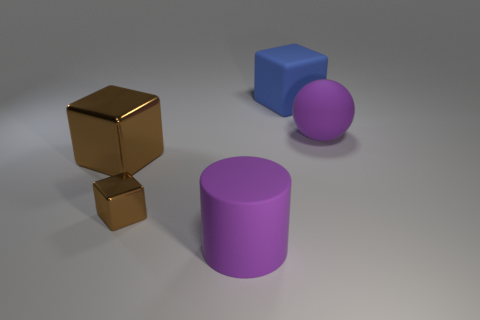Does the big sphere have the same color as the big cylinder?
Provide a succinct answer. Yes. Is there anything else that is the same shape as the small thing?
Keep it short and to the point. Yes. There is a large cube behind the object right of the blue matte block; what is it made of?
Ensure brevity in your answer.  Rubber. What is the size of the matte object that is to the left of the blue rubber object?
Make the answer very short. Large. There is a object that is both in front of the large metal object and on the left side of the purple matte cylinder; what color is it?
Ensure brevity in your answer.  Brown. There is a purple thing that is on the left side of the purple matte sphere; is its size the same as the big blue cube?
Your response must be concise. Yes. There is a rubber object behind the big purple ball; are there any large blue things left of it?
Offer a terse response. No. What is the material of the big brown thing?
Offer a very short reply. Metal. There is a large purple cylinder; are there any large rubber spheres in front of it?
Ensure brevity in your answer.  No. What is the size of the other metal object that is the same shape as the large metallic thing?
Make the answer very short. Small. 